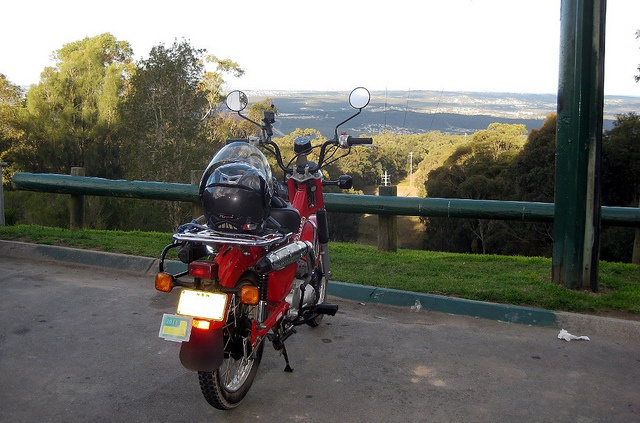Describe the objects in this image and their specific colors. I can see a motorcycle in white, black, maroon, and gray tones in this image. 